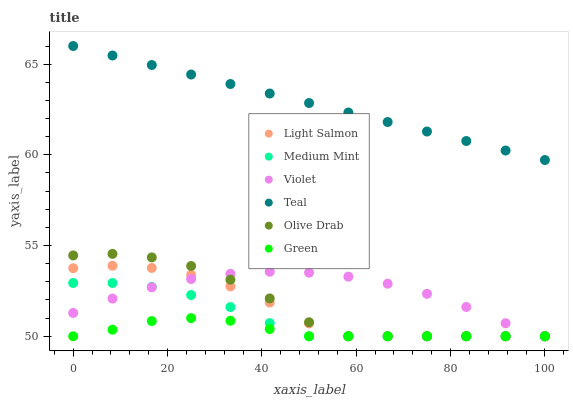Does Green have the minimum area under the curve?
Answer yes or no. Yes. Does Teal have the maximum area under the curve?
Answer yes or no. Yes. Does Light Salmon have the minimum area under the curve?
Answer yes or no. No. Does Light Salmon have the maximum area under the curve?
Answer yes or no. No. Is Teal the smoothest?
Answer yes or no. Yes. Is Olive Drab the roughest?
Answer yes or no. Yes. Is Light Salmon the smoothest?
Answer yes or no. No. Is Light Salmon the roughest?
Answer yes or no. No. Does Medium Mint have the lowest value?
Answer yes or no. Yes. Does Teal have the lowest value?
Answer yes or no. No. Does Teal have the highest value?
Answer yes or no. Yes. Does Light Salmon have the highest value?
Answer yes or no. No. Is Medium Mint less than Teal?
Answer yes or no. Yes. Is Teal greater than Violet?
Answer yes or no. Yes. Does Violet intersect Green?
Answer yes or no. Yes. Is Violet less than Green?
Answer yes or no. No. Is Violet greater than Green?
Answer yes or no. No. Does Medium Mint intersect Teal?
Answer yes or no. No. 